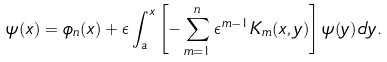Convert formula to latex. <formula><loc_0><loc_0><loc_500><loc_500>\psi ( x ) = \phi _ { n } ( x ) + \epsilon \int ^ { x } _ { a } \left [ - \sum ^ { n } _ { m = 1 } \epsilon ^ { m - 1 } K _ { m } ( x , y ) \right ] \psi ( y ) \, d y .</formula> 